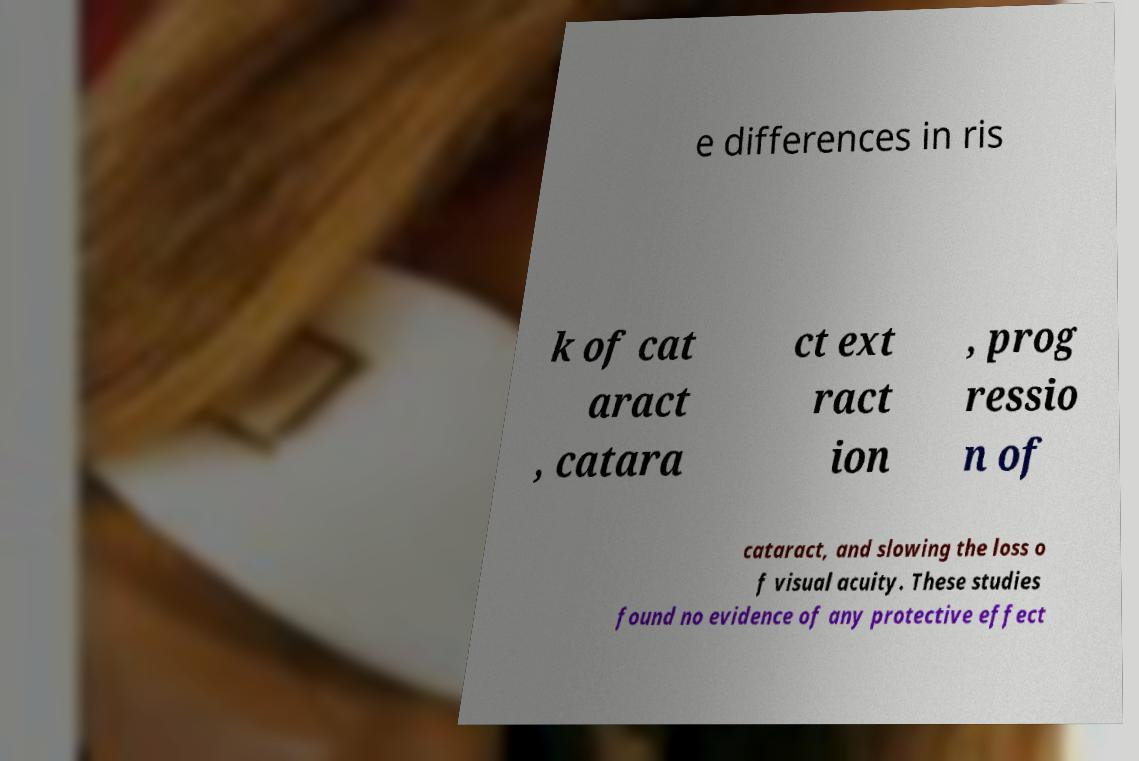Please read and relay the text visible in this image. What does it say? e differences in ris k of cat aract , catara ct ext ract ion , prog ressio n of cataract, and slowing the loss o f visual acuity. These studies found no evidence of any protective effect 